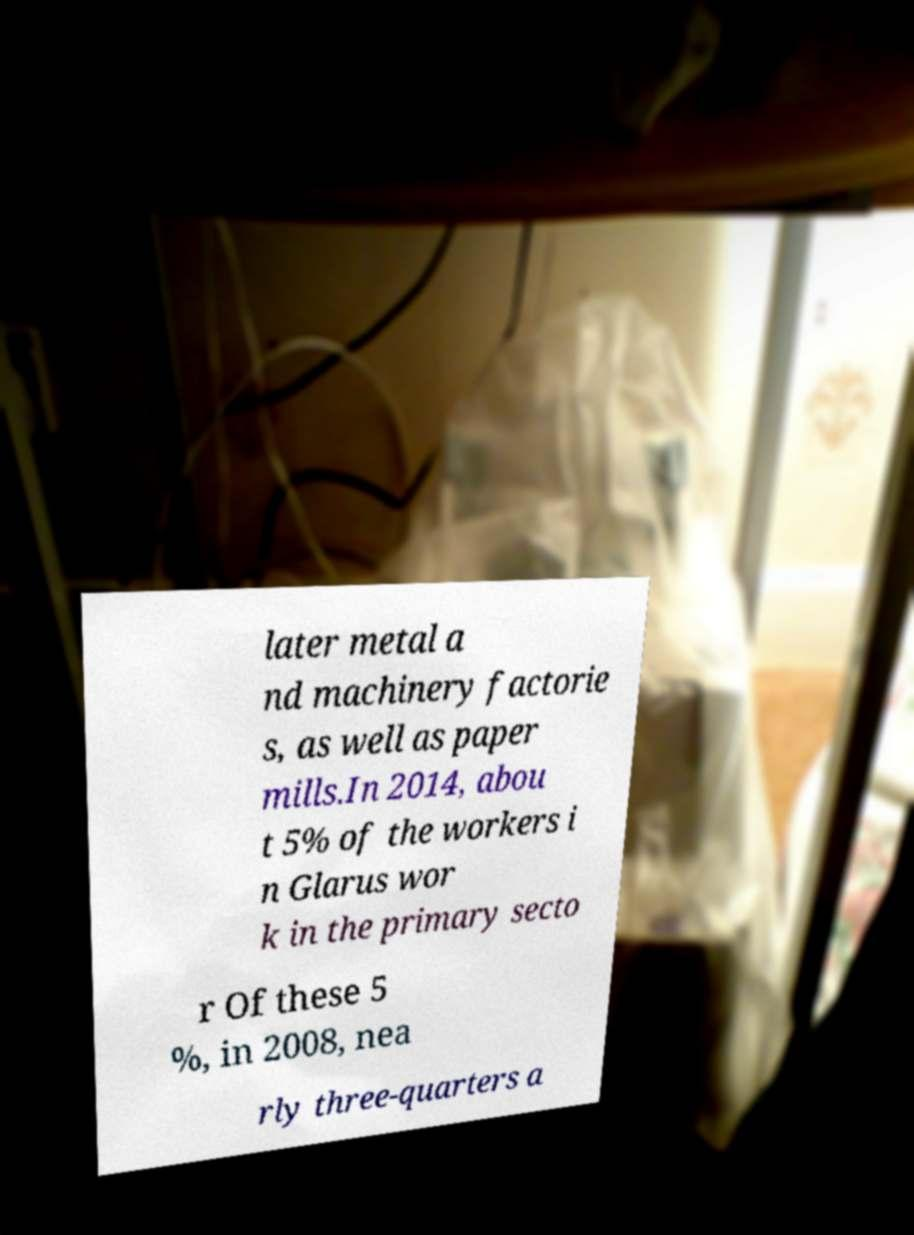Can you accurately transcribe the text from the provided image for me? later metal a nd machinery factorie s, as well as paper mills.In 2014, abou t 5% of the workers i n Glarus wor k in the primary secto r Of these 5 %, in 2008, nea rly three-quarters a 